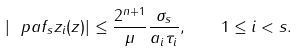<formula> <loc_0><loc_0><loc_500><loc_500>\left | \ p a { f _ { s } } { z _ { i } } ( z ) \right | \leq \frac { 2 ^ { n + 1 } } { \mu } \frac { \sigma _ { s } } { a _ { i } \tau _ { i } } , \quad 1 \leq i < s .</formula> 